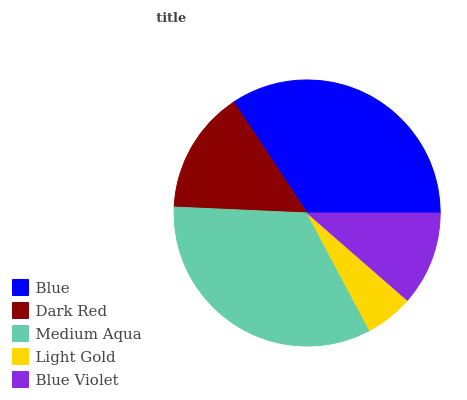Is Light Gold the minimum?
Answer yes or no. Yes. Is Blue the maximum?
Answer yes or no. Yes. Is Dark Red the minimum?
Answer yes or no. No. Is Dark Red the maximum?
Answer yes or no. No. Is Blue greater than Dark Red?
Answer yes or no. Yes. Is Dark Red less than Blue?
Answer yes or no. Yes. Is Dark Red greater than Blue?
Answer yes or no. No. Is Blue less than Dark Red?
Answer yes or no. No. Is Dark Red the high median?
Answer yes or no. Yes. Is Dark Red the low median?
Answer yes or no. Yes. Is Blue Violet the high median?
Answer yes or no. No. Is Blue the low median?
Answer yes or no. No. 